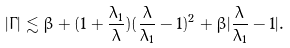Convert formula to latex. <formula><loc_0><loc_0><loc_500><loc_500>| \Gamma | \lesssim \beta + ( 1 + \frac { \lambda _ { 1 } } { \lambda } ) ( \frac { \lambda } { \lambda _ { 1 } } - 1 ) ^ { 2 } + \beta | \frac { \lambda } { \lambda _ { 1 } } - 1 | .</formula> 